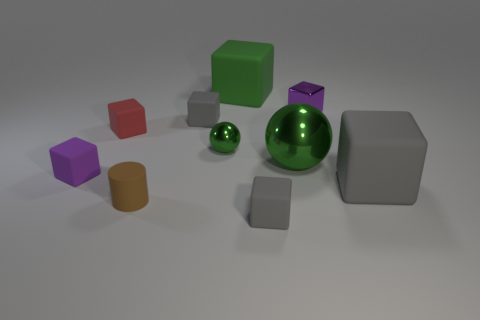Subtract all matte cubes. How many cubes are left? 1 Subtract all cylinders. How many objects are left? 9 Subtract all red cubes. How many cubes are left? 6 Subtract 6 cubes. How many cubes are left? 1 Add 3 small red cubes. How many small red cubes are left? 4 Add 4 big blue matte blocks. How many big blue matte blocks exist? 4 Subtract 1 gray cubes. How many objects are left? 9 Subtract all cyan spheres. Subtract all blue cylinders. How many spheres are left? 2 Subtract all cyan cylinders. How many blue spheres are left? 0 Subtract all purple blocks. Subtract all tiny gray objects. How many objects are left? 6 